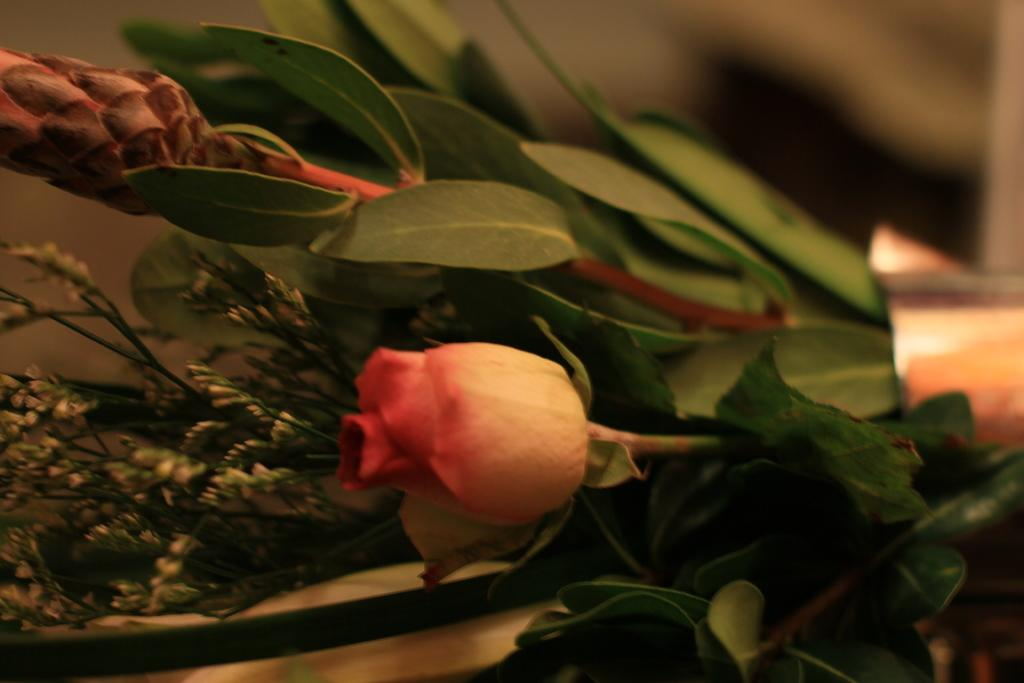What type of plant life can be seen in the image? There are flowers and leaves in the image. Can you describe the flowers in the image? Unfortunately, the facts provided do not give specific details about the flowers. What is the color of the leaves in the image? The facts provided do not specify the color of the leaves. What type of bell can be seen in the image? There is no bell present in the image. How is the quill used in the image? There is no quill present in the image. 